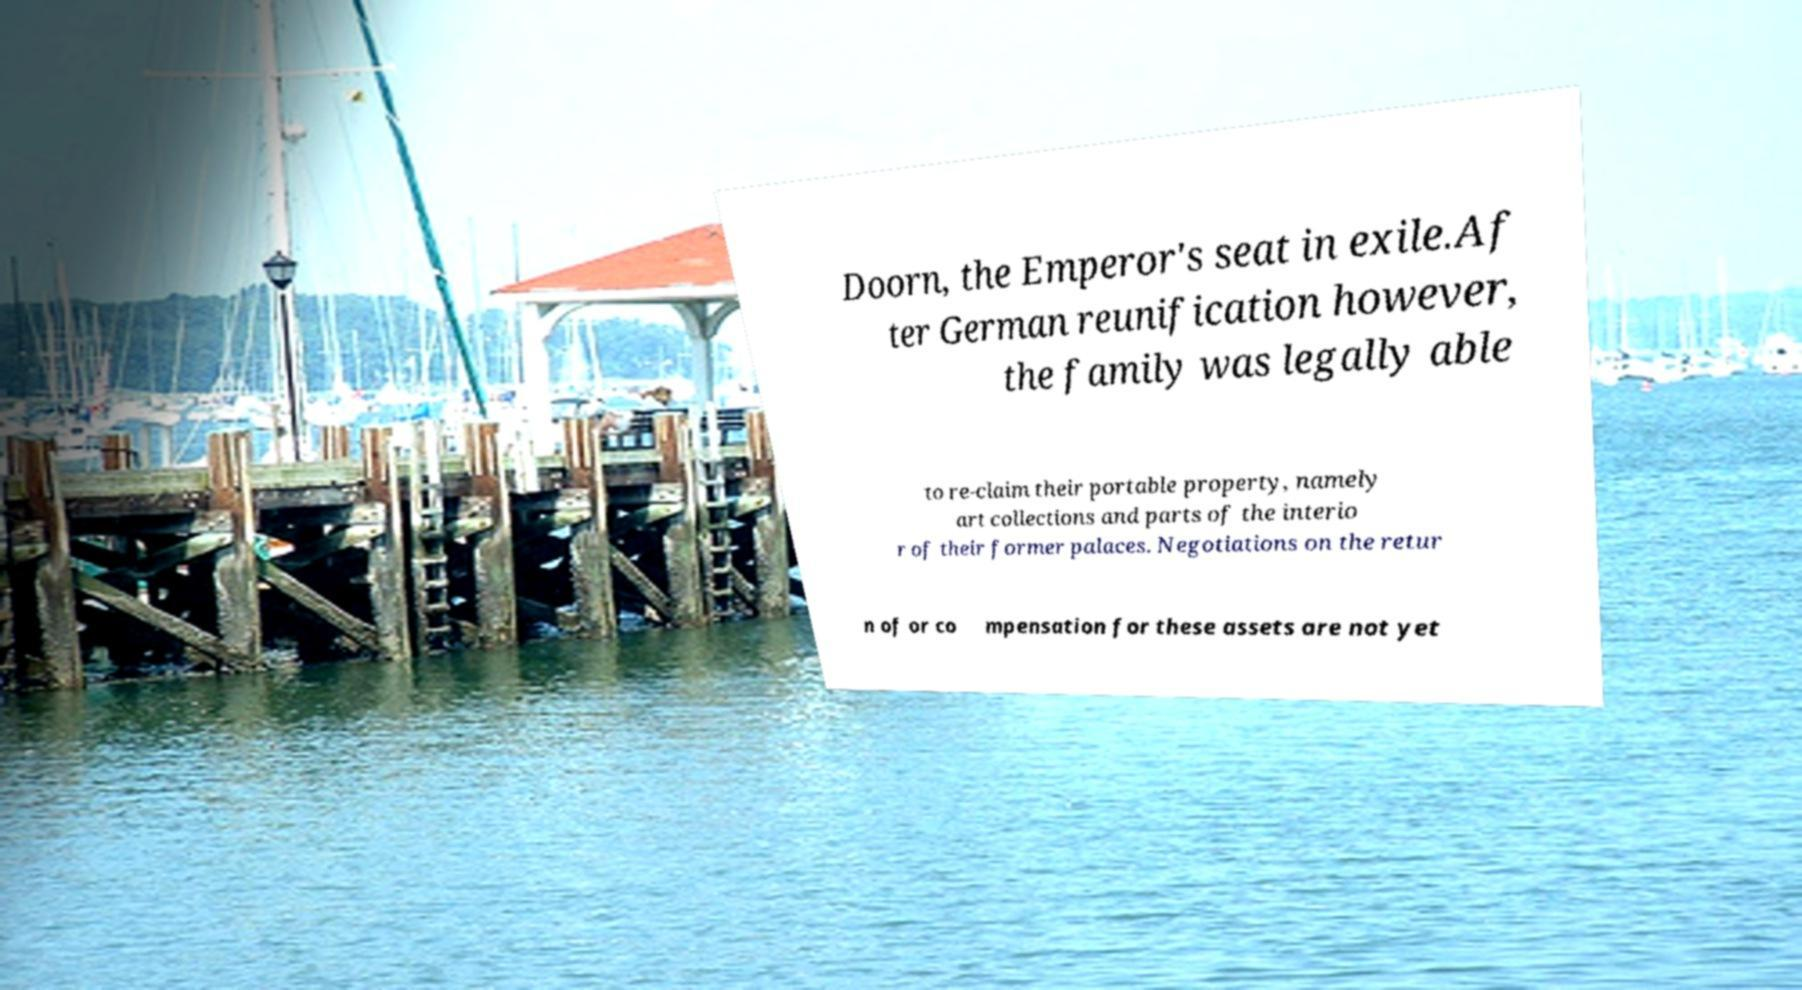Could you extract and type out the text from this image? Doorn, the Emperor's seat in exile.Af ter German reunification however, the family was legally able to re-claim their portable property, namely art collections and parts of the interio r of their former palaces. Negotiations on the retur n of or co mpensation for these assets are not yet 